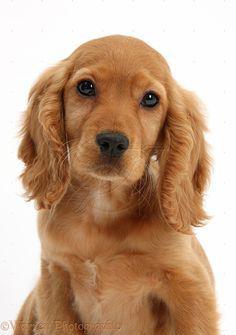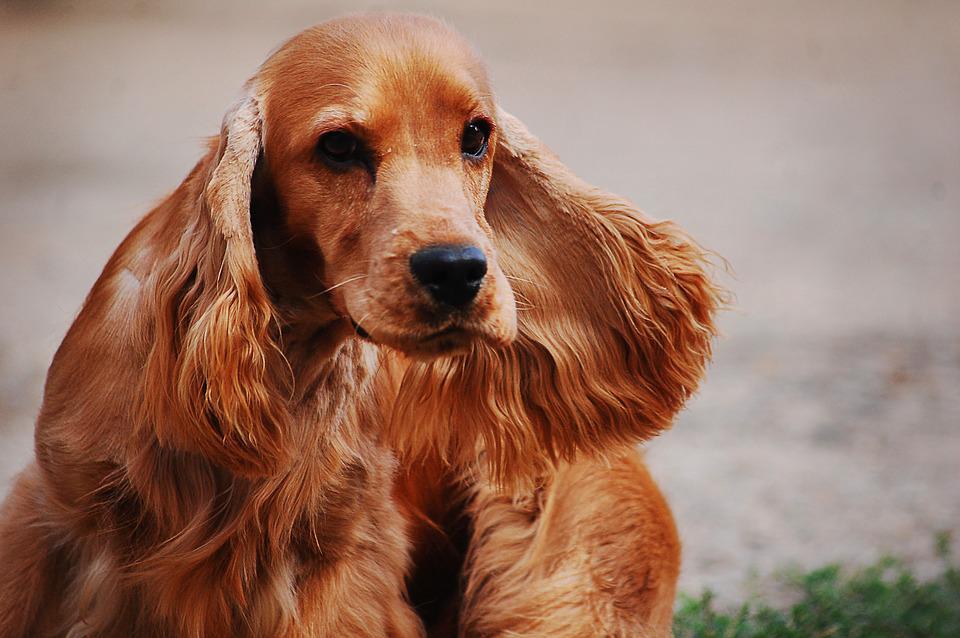The first image is the image on the left, the second image is the image on the right. For the images shown, is this caption "the dog on the right image is facing right" true? Answer yes or no. Yes. 